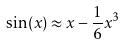<formula> <loc_0><loc_0><loc_500><loc_500>\sin ( x ) \approx x - \frac { 1 } { 6 } x ^ { 3 }</formula> 